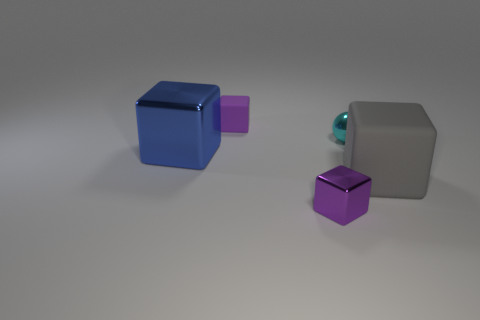What is the shape of the thing that is on the right side of the tiny shiny block and behind the gray rubber thing?
Provide a short and direct response. Sphere. Are there any other things that have the same size as the blue metal thing?
Offer a terse response. Yes. There is a blue thing that is made of the same material as the small ball; what is its size?
Make the answer very short. Large. How many objects are tiny objects that are in front of the large gray object or things that are behind the small ball?
Ensure brevity in your answer.  2. Is the size of the purple object that is behind the metal sphere the same as the big rubber thing?
Offer a very short reply. No. The large metal cube that is in front of the cyan metallic ball is what color?
Keep it short and to the point. Blue. There is another large object that is the same shape as the large metallic object; what is its color?
Your answer should be very brief. Gray. How many large shiny objects are to the right of the purple cube in front of the tiny ball that is right of the blue metallic thing?
Ensure brevity in your answer.  0. Is there any other thing that is made of the same material as the blue thing?
Give a very brief answer. Yes. Are there fewer large blue cubes in front of the large blue metallic thing than tiny purple matte objects?
Make the answer very short. Yes. 